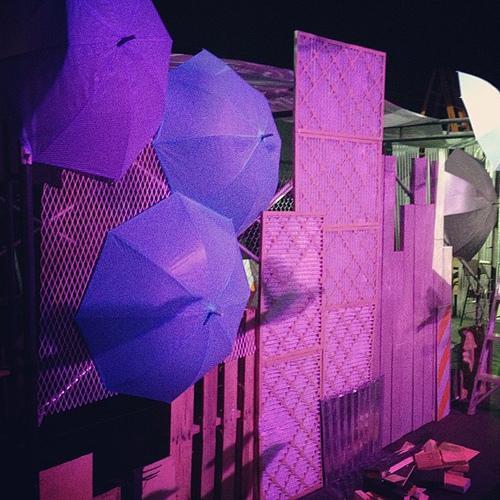How many umbrellas are shown?
Give a very brief answer. 5. How many sections are there on the tallest wall?
Give a very brief answer. 4. 